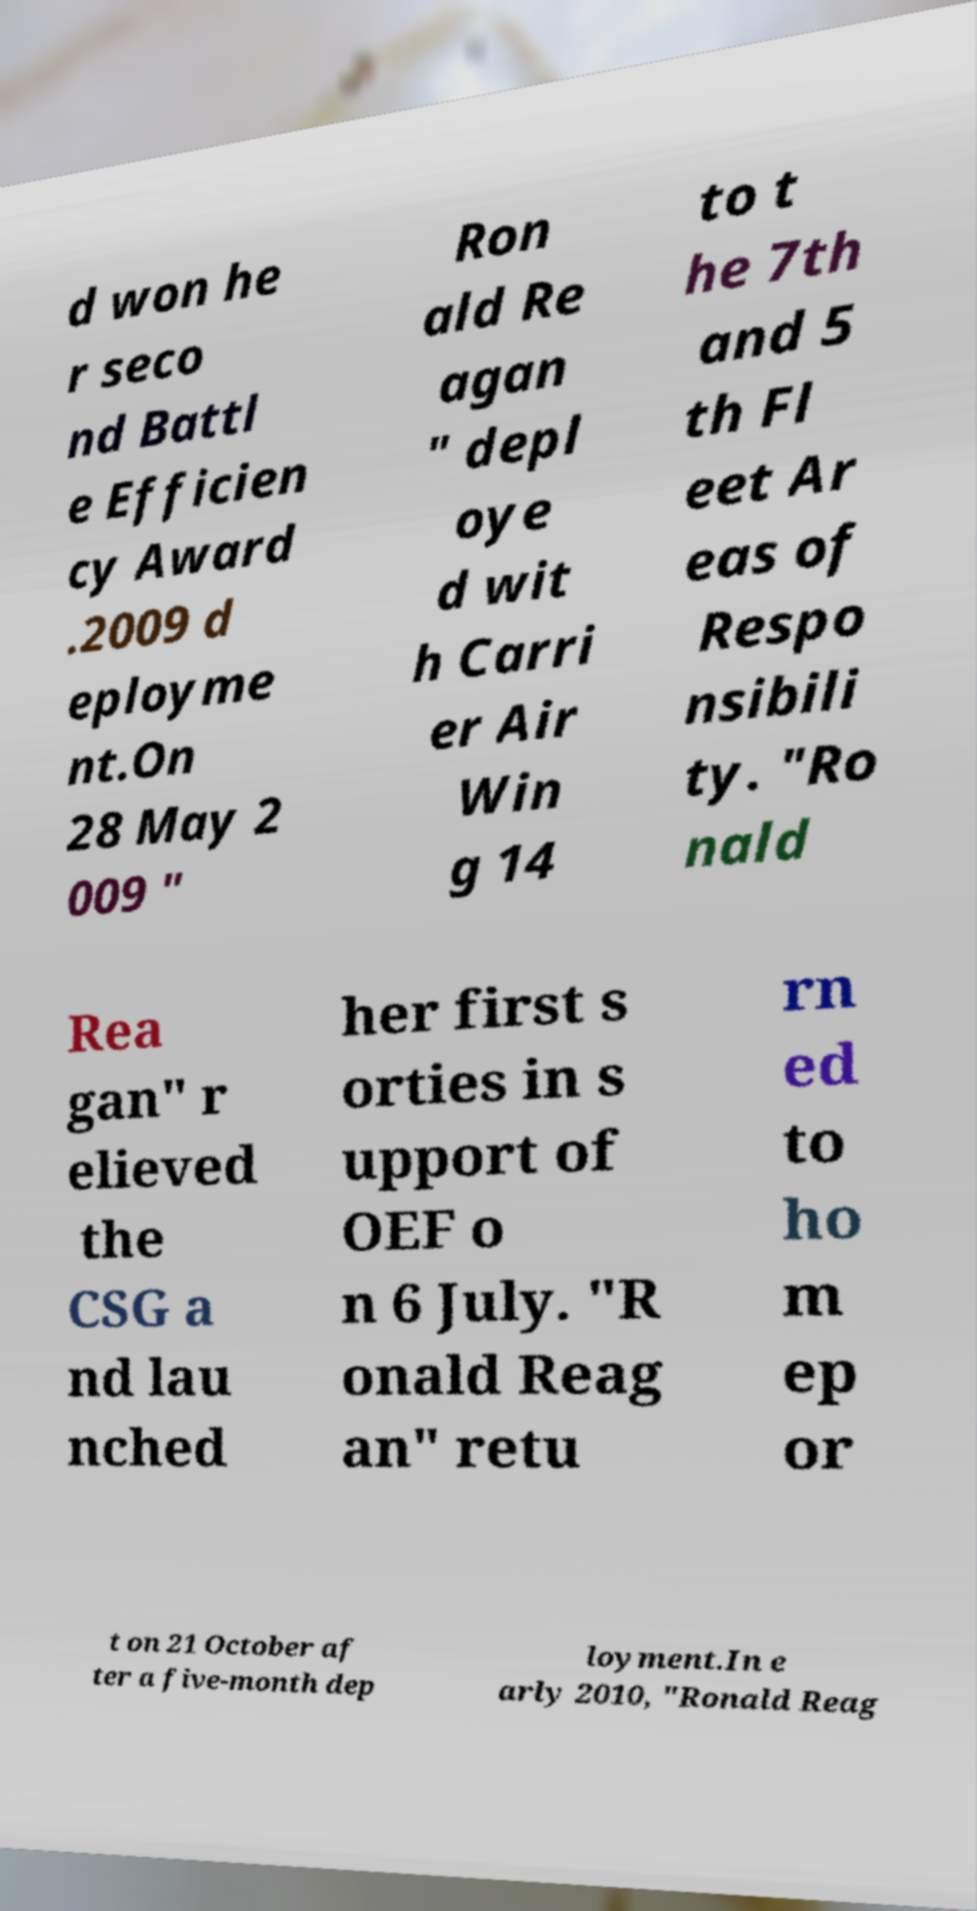Could you extract and type out the text from this image? d won he r seco nd Battl e Efficien cy Award .2009 d eployme nt.On 28 May 2 009 " Ron ald Re agan " depl oye d wit h Carri er Air Win g 14 to t he 7th and 5 th Fl eet Ar eas of Respo nsibili ty. "Ro nald Rea gan" r elieved the CSG a nd lau nched her first s orties in s upport of OEF o n 6 July. "R onald Reag an" retu rn ed to ho m ep or t on 21 October af ter a five-month dep loyment.In e arly 2010, "Ronald Reag 